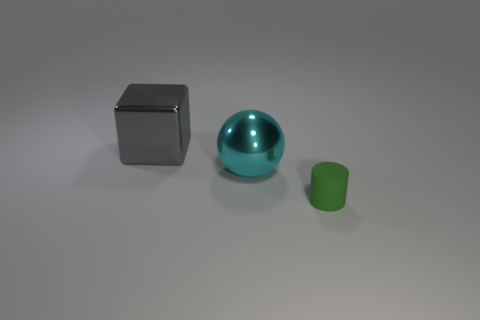Add 2 small matte things. How many objects exist? 5 Subtract 0 blue cylinders. How many objects are left? 3 Subtract 1 spheres. How many spheres are left? 0 Subtract all gray balls. Subtract all brown cylinders. How many balls are left? 1 Subtract all purple cubes. How many gray spheres are left? 0 Subtract all gray blocks. Subtract all tiny green cylinders. How many objects are left? 1 Add 3 cyan metal things. How many cyan metal things are left? 4 Add 2 gray things. How many gray things exist? 3 